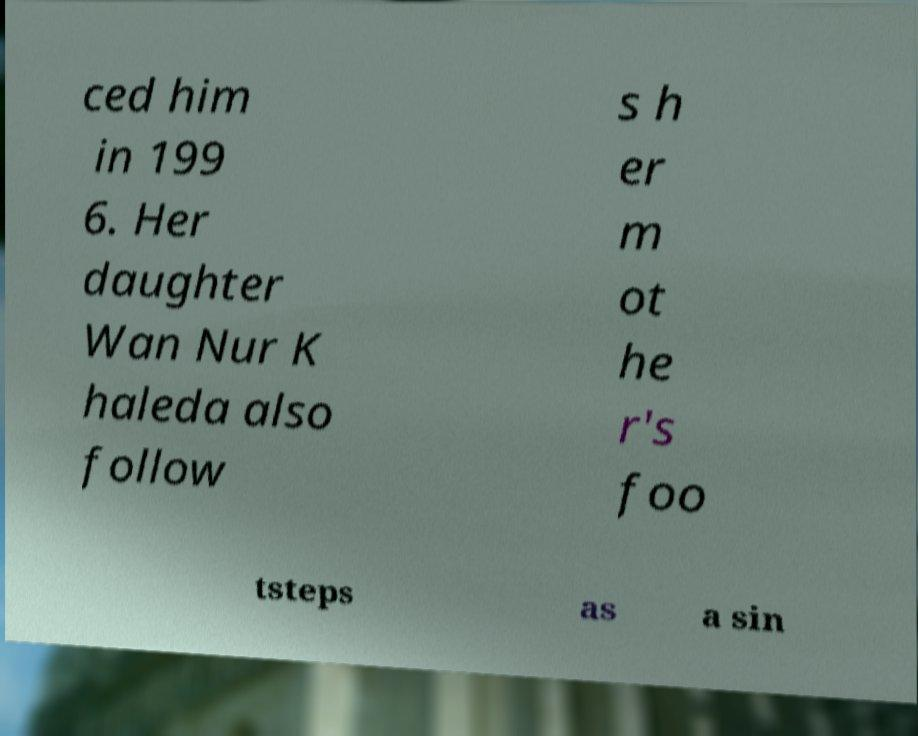For documentation purposes, I need the text within this image transcribed. Could you provide that? ced him in 199 6. Her daughter Wan Nur K haleda also follow s h er m ot he r's foo tsteps as a sin 